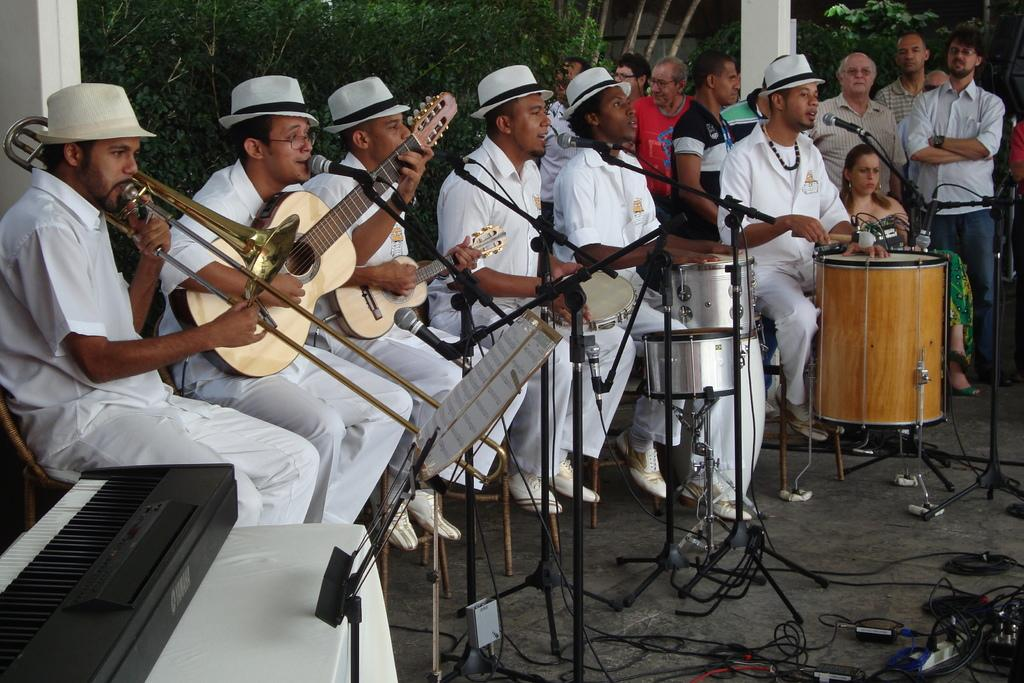What is happening in the image involving a group of people? The people in the image are playing musical instruments. How are the people positioned in the image? The people are sitting on chairs. What are the people wearing on their heads? The people are wearing caps. What can be seen in the background of the image? There are trees and pillars visible in the background of the image. What type of picture is hanging on the wall in the image? There is no picture hanging on the wall in the image; it only shows a group of people playing musical instruments. Can you tell me how many pickles are on the table in the image? There are no pickles present in the image. 